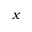<formula> <loc_0><loc_0><loc_500><loc_500>x</formula> 